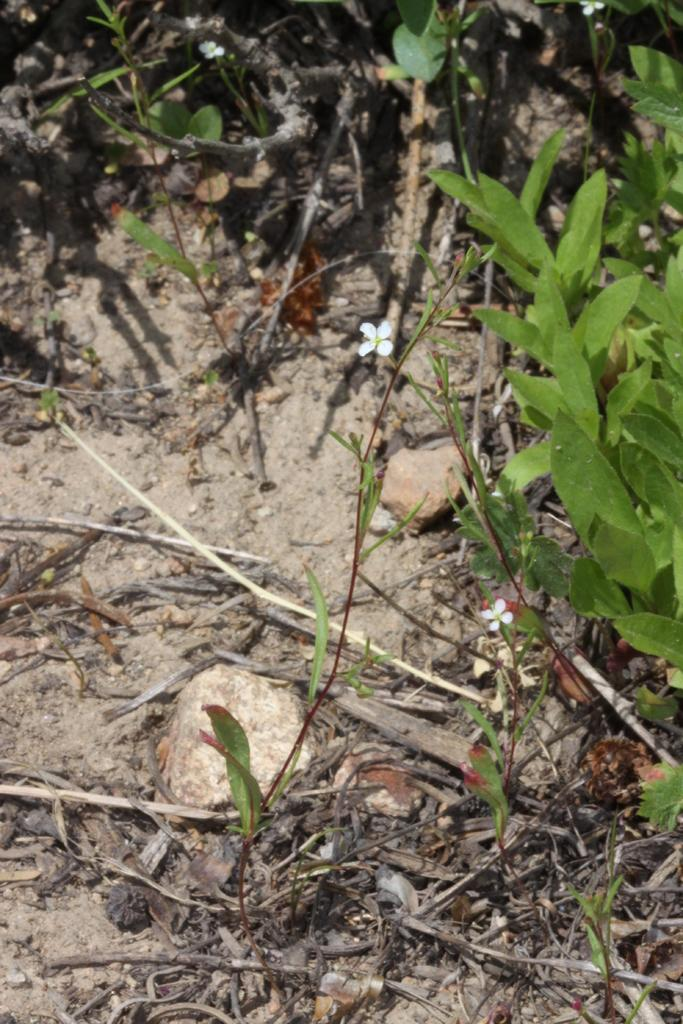What type of vegetation can be seen in the image? There are plants and grass in the image. Can you describe a specific flower in the image? Yes, there is a small white flower in the image. What is located on the bottom left of the image? There is a stone on the bottom left of the image. What time of day is it in the image, based on the hour? The provided facts do not mention the time of day or any hour, so it cannot be determined from the image. 